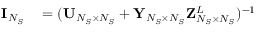Convert formula to latex. <formula><loc_0><loc_0><loc_500><loc_500>\begin{array} { r l } { { I } _ { N _ { S } } } & = ( { U } _ { N _ { S } \times N _ { S } } + { Y } _ { N _ { S } \times N _ { S } } { Z } _ { N _ { S } \times N _ { S } } ^ { L } ) ^ { - 1 } } \end{array}</formula> 